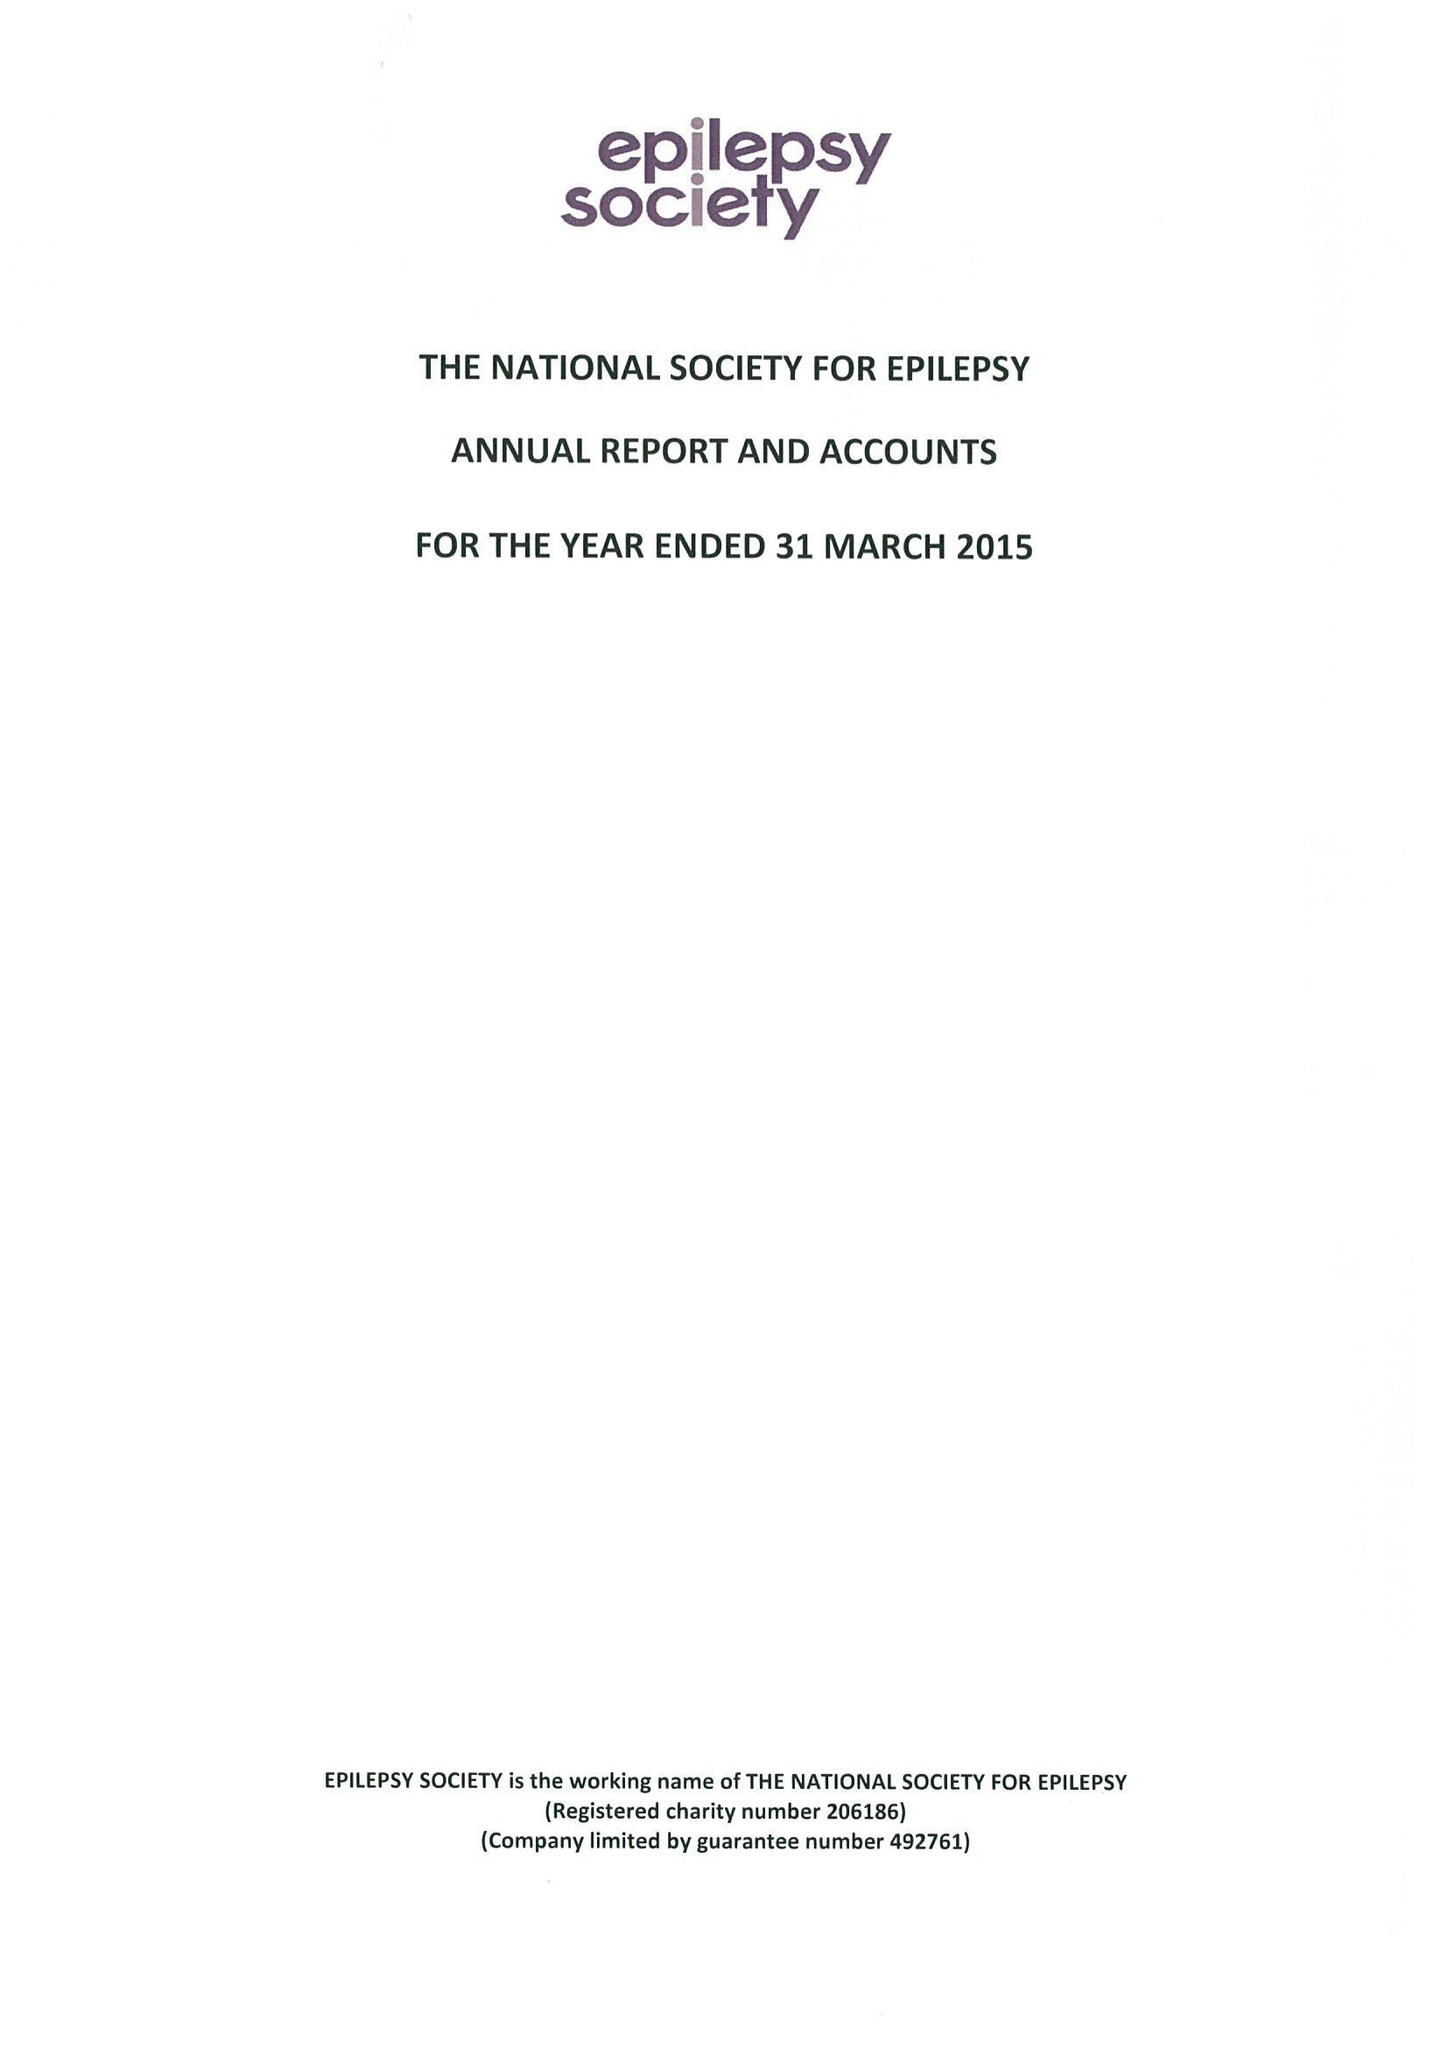What is the value for the charity_number?
Answer the question using a single word or phrase. 206186 